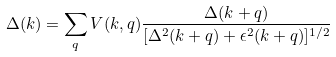<formula> <loc_0><loc_0><loc_500><loc_500>\Delta ( { k } ) = \sum _ { q } V ( { k , q } ) \frac { \Delta ( { k + q } ) } { [ \Delta ^ { 2 } ( { k + q } ) + \epsilon ^ { 2 } ( { k + q } ) ] ^ { 1 / 2 } }</formula> 